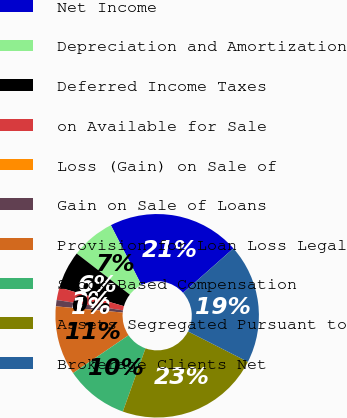Convert chart to OTSL. <chart><loc_0><loc_0><loc_500><loc_500><pie_chart><fcel>Net Income<fcel>Depreciation and Amortization<fcel>Deferred Income Taxes<fcel>on Available for Sale<fcel>Loss (Gain) on Sale of<fcel>Gain on Sale of Loans<fcel>Provision for Loan Loss Legal<fcel>Stock-Based Compensation<fcel>Assets Segregated Pursuant to<fcel>Brokerage Clients Net<nl><fcel>21.0%<fcel>7.0%<fcel>6.0%<fcel>2.0%<fcel>0.0%<fcel>1.0%<fcel>11.0%<fcel>10.0%<fcel>23.0%<fcel>19.0%<nl></chart> 